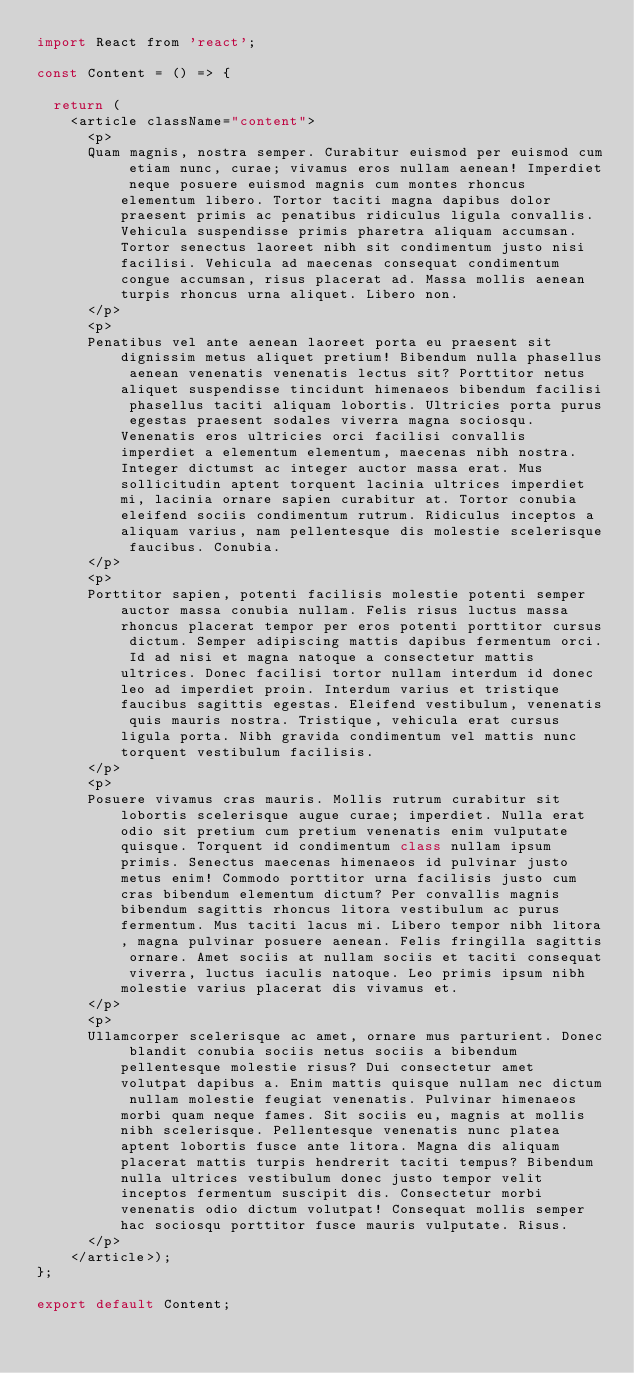<code> <loc_0><loc_0><loc_500><loc_500><_JavaScript_>import React from 'react';

const Content = () => {

  return (
    <article className="content">
      <p>
      Quam magnis, nostra semper. Curabitur euismod per euismod cum etiam nunc, curae; vivamus eros nullam aenean! Imperdiet neque posuere euismod magnis cum montes rhoncus elementum libero. Tortor taciti magna dapibus dolor praesent primis ac penatibus ridiculus ligula convallis. Vehicula suspendisse primis pharetra aliquam accumsan. Tortor senectus laoreet nibh sit condimentum justo nisi facilisi. Vehicula ad maecenas consequat condimentum congue accumsan, risus placerat ad. Massa mollis aenean turpis rhoncus urna aliquet. Libero non.
      </p>
      <p>
      Penatibus vel ante aenean laoreet porta eu praesent sit dignissim metus aliquet pretium! Bibendum nulla phasellus aenean venenatis venenatis lectus sit? Porttitor netus aliquet suspendisse tincidunt himenaeos bibendum facilisi phasellus taciti aliquam lobortis. Ultricies porta purus egestas praesent sodales viverra magna sociosqu. Venenatis eros ultricies orci facilisi convallis imperdiet a elementum elementum, maecenas nibh nostra. Integer dictumst ac integer auctor massa erat. Mus sollicitudin aptent torquent lacinia ultrices imperdiet mi, lacinia ornare sapien curabitur at. Tortor conubia eleifend sociis condimentum rutrum. Ridiculus inceptos a aliquam varius, nam pellentesque dis molestie scelerisque faucibus. Conubia.
      </p>
      <p>
      Porttitor sapien, potenti facilisis molestie potenti semper auctor massa conubia nullam. Felis risus luctus massa rhoncus placerat tempor per eros potenti porttitor cursus dictum. Semper adipiscing mattis dapibus fermentum orci. Id ad nisi et magna natoque a consectetur mattis ultrices. Donec facilisi tortor nullam interdum id donec leo ad imperdiet proin. Interdum varius et tristique faucibus sagittis egestas. Eleifend vestibulum, venenatis quis mauris nostra. Tristique, vehicula erat cursus ligula porta. Nibh gravida condimentum vel mattis nunc torquent vestibulum facilisis.
      </p>
      <p>
      Posuere vivamus cras mauris. Mollis rutrum curabitur sit lobortis scelerisque augue curae; imperdiet. Nulla erat odio sit pretium cum pretium venenatis enim vulputate quisque. Torquent id condimentum class nullam ipsum primis. Senectus maecenas himenaeos id pulvinar justo metus enim! Commodo porttitor urna facilisis justo cum cras bibendum elementum dictum? Per convallis magnis bibendum sagittis rhoncus litora vestibulum ac purus fermentum. Mus taciti lacus mi. Libero tempor nibh litora, magna pulvinar posuere aenean. Felis fringilla sagittis ornare. Amet sociis at nullam sociis et taciti consequat viverra, luctus iaculis natoque. Leo primis ipsum nibh molestie varius placerat dis vivamus et.
      </p>
      <p>
      Ullamcorper scelerisque ac amet, ornare mus parturient. Donec blandit conubia sociis netus sociis a bibendum pellentesque molestie risus? Dui consectetur amet volutpat dapibus a. Enim mattis quisque nullam nec dictum nullam molestie feugiat venenatis. Pulvinar himenaeos morbi quam neque fames. Sit sociis eu, magnis at mollis nibh scelerisque. Pellentesque venenatis nunc platea aptent lobortis fusce ante litora. Magna dis aliquam placerat mattis turpis hendrerit taciti tempus? Bibendum nulla ultrices vestibulum donec justo tempor velit inceptos fermentum suscipit dis. Consectetur morbi venenatis odio dictum volutpat! Consequat mollis semper hac sociosqu porttitor fusce mauris vulputate. Risus.
      </p>
    </article>);
};

export default Content;
</code> 